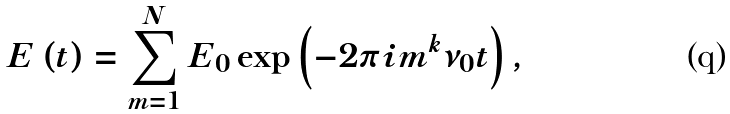<formula> <loc_0><loc_0><loc_500><loc_500>E \left ( t \right ) = \sum _ { m = 1 } ^ { N } E _ { 0 } \exp \left ( - 2 \pi i m ^ { k } \nu _ { 0 } t \right ) ,</formula> 